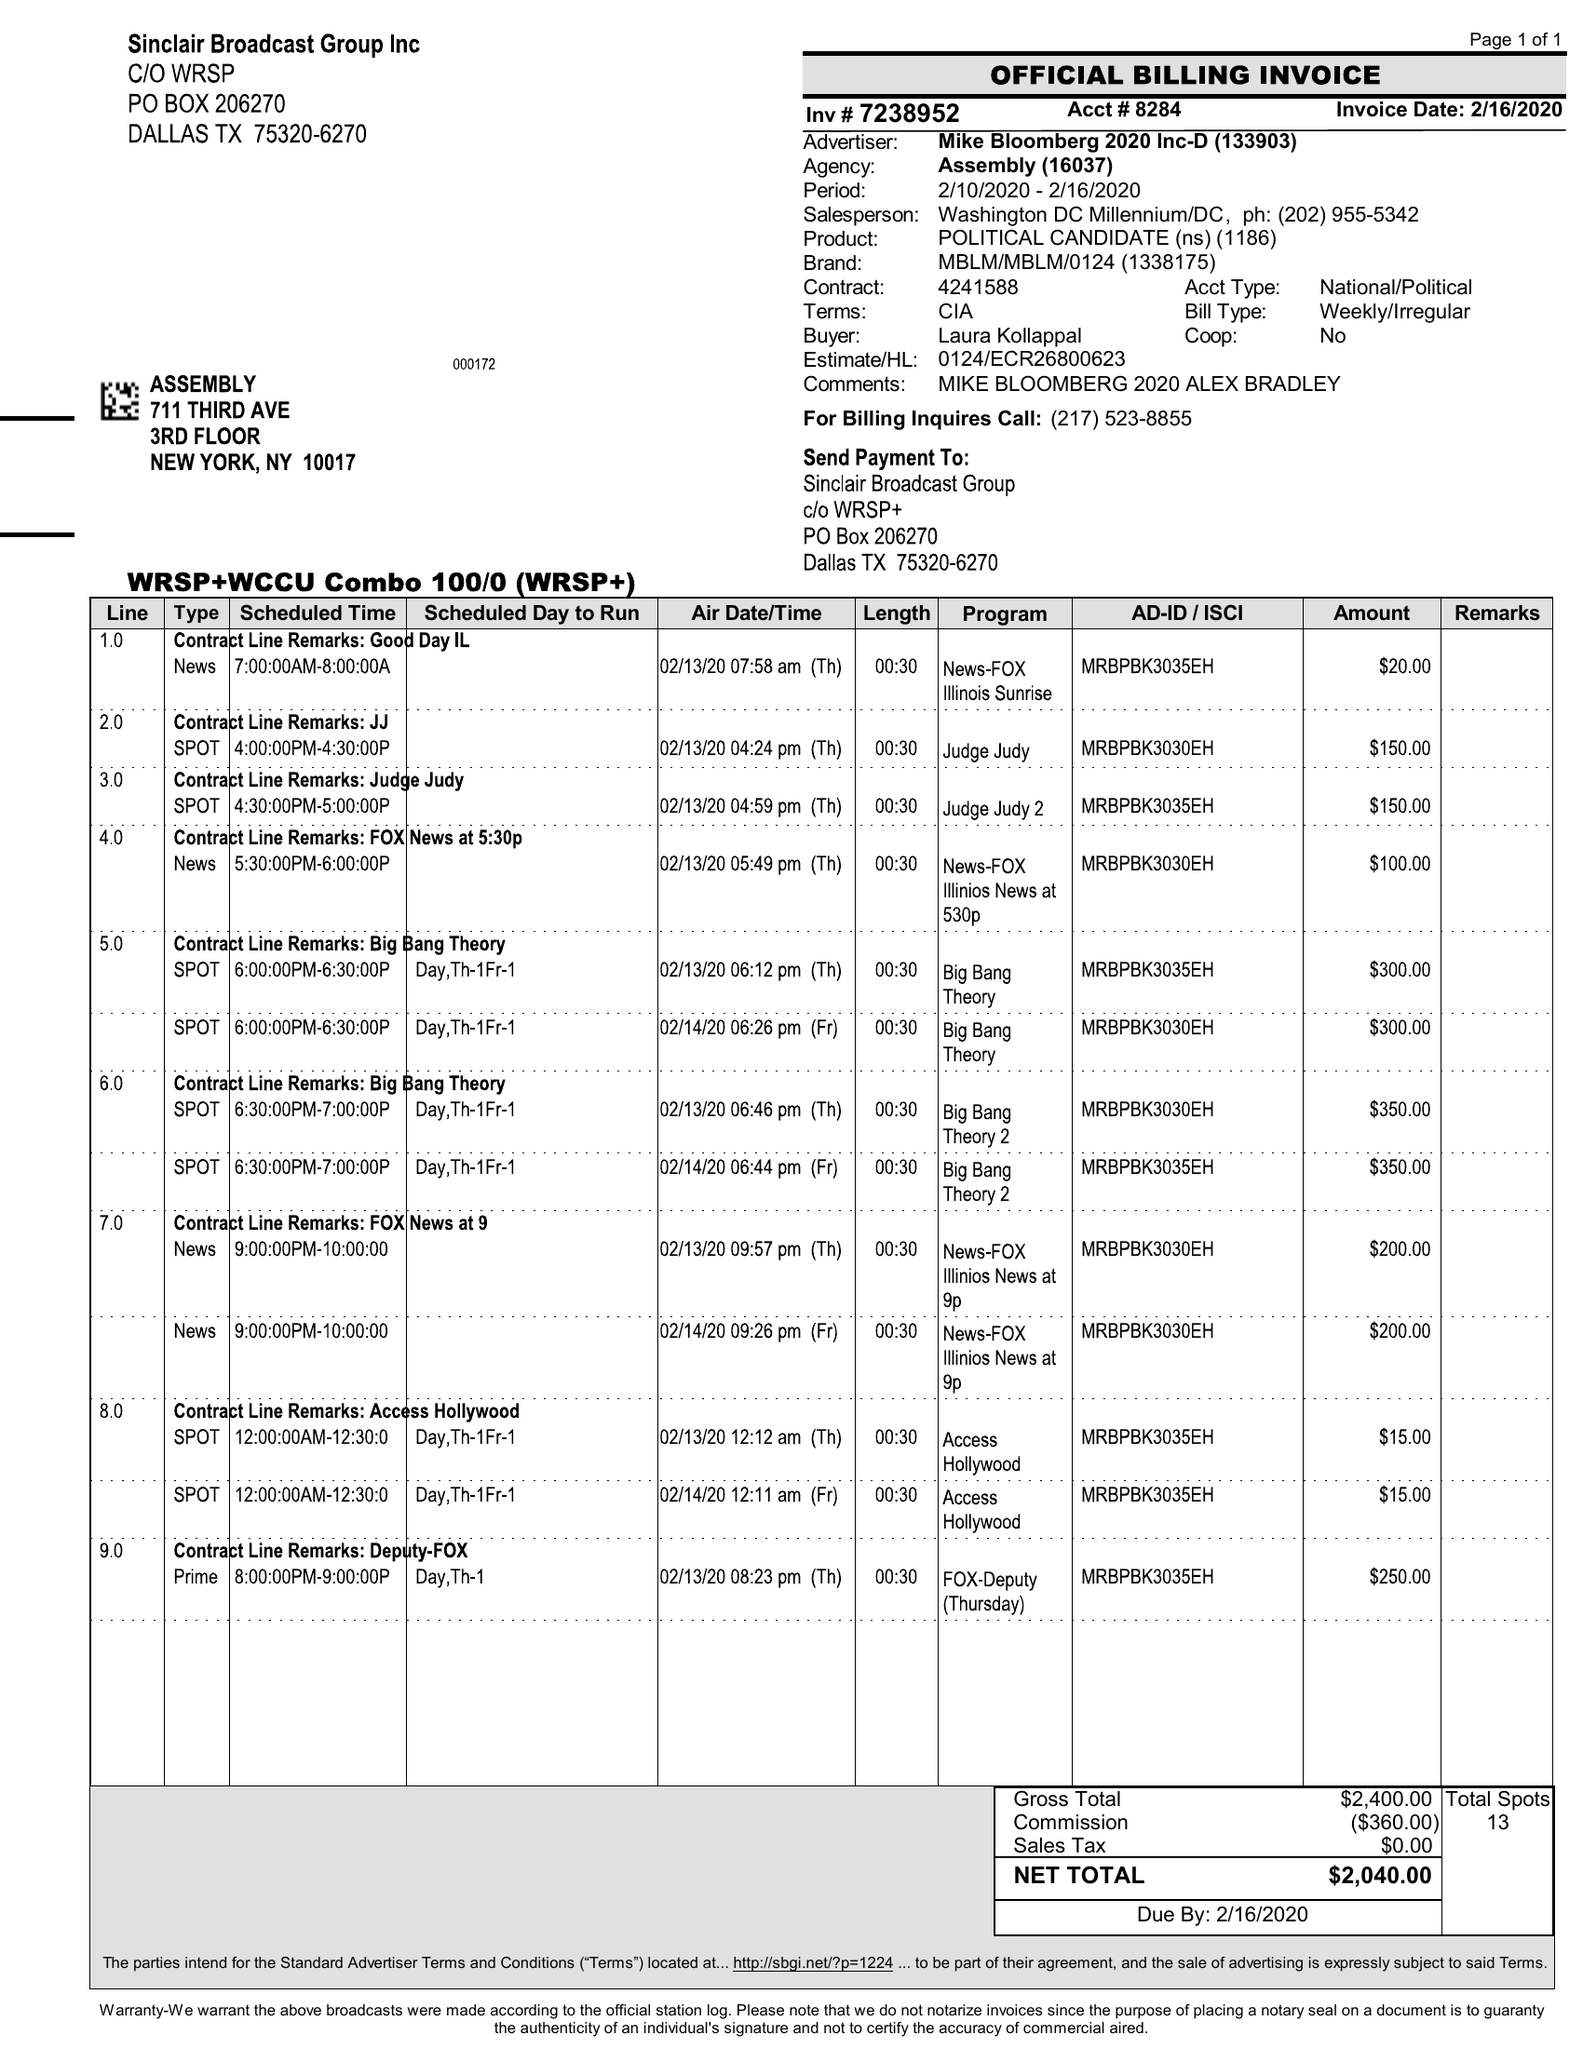What is the value for the flight_from?
Answer the question using a single word or phrase. 02/10/20 